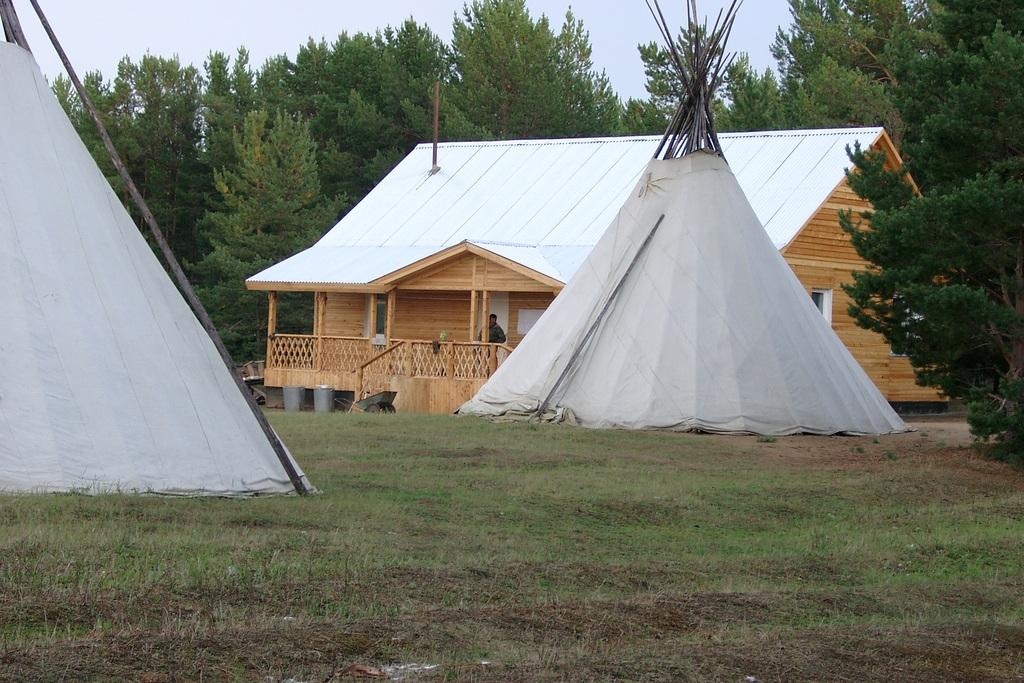What is the main structure in the center of the image? There is a shed in the center of the image. Who or what is inside the shed? A man is standing in the shed. What type of temporary shelters can be seen at the bottom of the image? There are tents at the bottom of the image. What can be seen in the background of the image? There are trees and the sky visible in the background of the image. What type of engine is being repaired by the police in the image? There is no police or engine present in the image. How many potatoes are visible in the image? There are no potatoes present in the image. 